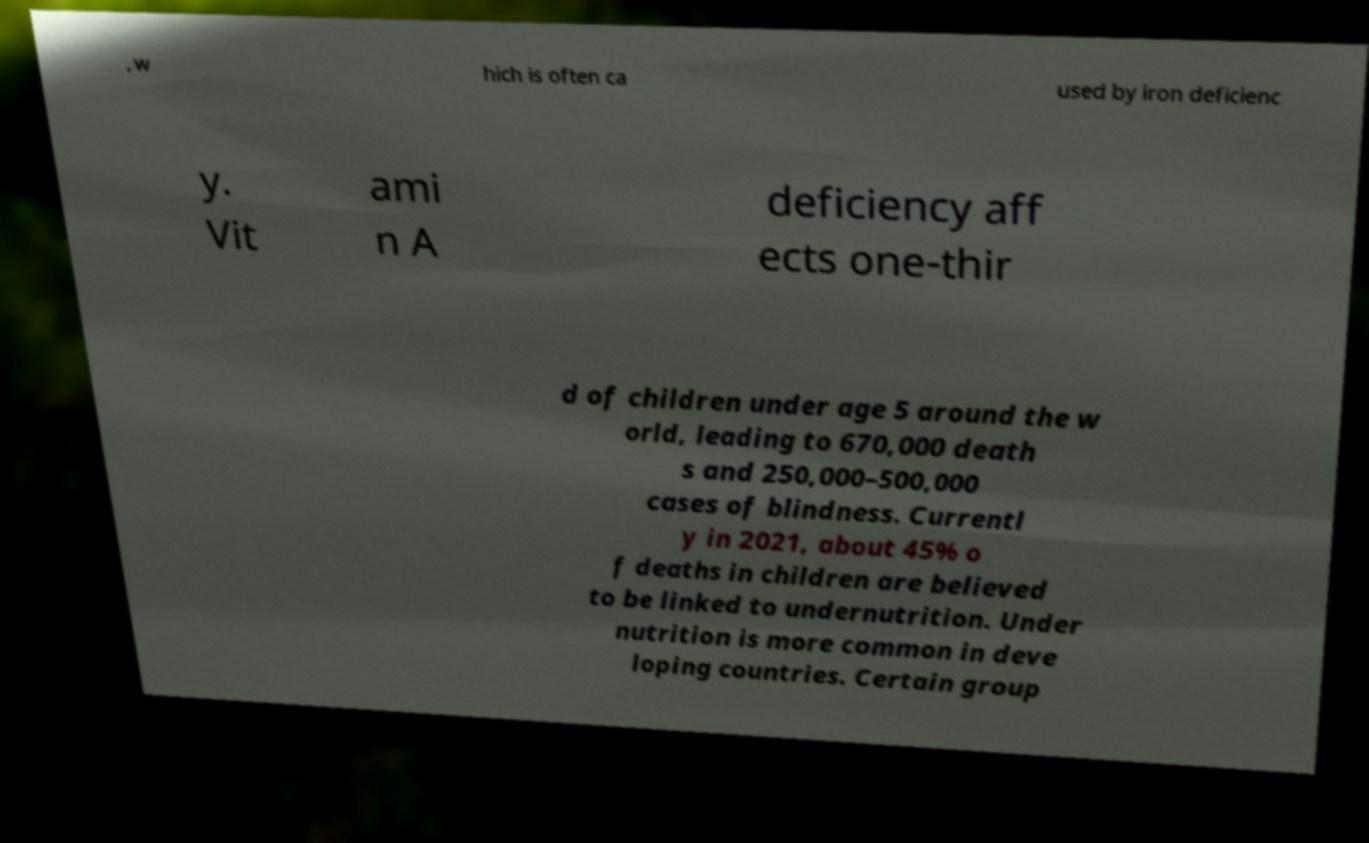Could you assist in decoding the text presented in this image and type it out clearly? , w hich is often ca used by iron deficienc y. Vit ami n A deficiency aff ects one-thir d of children under age 5 around the w orld, leading to 670,000 death s and 250,000–500,000 cases of blindness. Currentl y in 2021, about 45% o f deaths in children are believed to be linked to undernutrition. Under nutrition is more common in deve loping countries. Certain group 